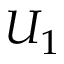<formula> <loc_0><loc_0><loc_500><loc_500>U _ { 1 }</formula> 